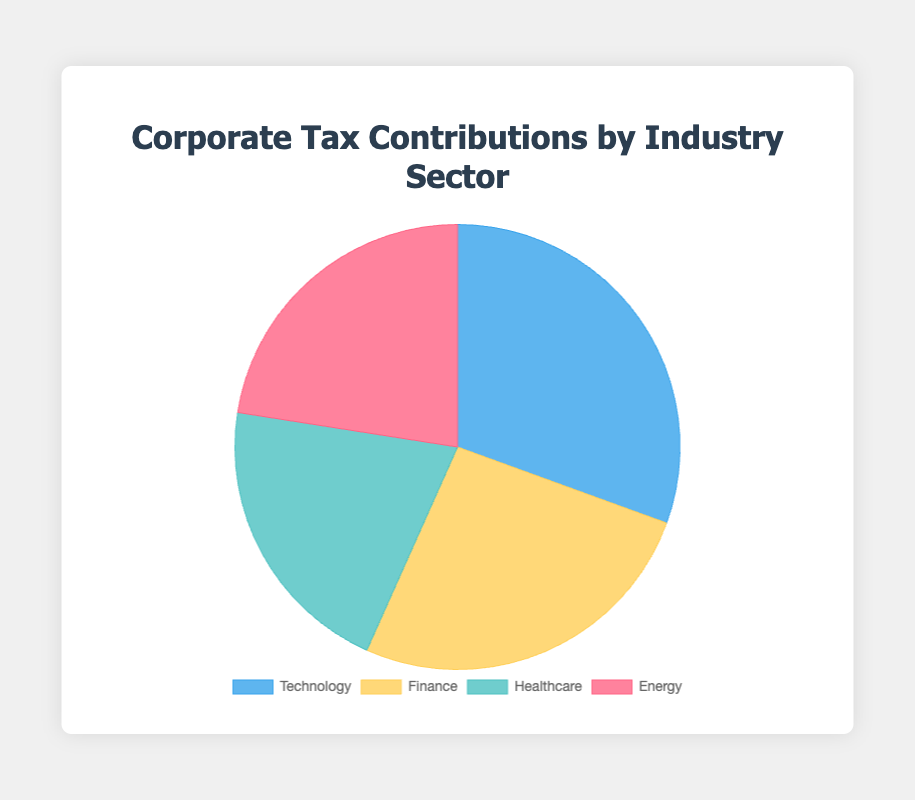Which industry sector has the highest corporate tax contributions? The pie chart shows four industry sectors with their respective tax contributions. By visually inspecting the chart, "Technology" has the largest segment.
Answer: Technology Which industry sector has the smallest corporate tax contributions? The chart segment with the smallest area represents the industry with the smallest tax contributions. This is "Healthcare".
Answer: Healthcare What is the combined tax contribution of the Finance and Energy sectors? By adding the tax contributions of Finance ($7,450) and Energy ($6,420), we get $7,450 + $6,420 = $13,870.
Answer: $13,870 How much more does Technology contribute in taxes compared to Healthcare? Subtract the tax contributions of Healthcare ($5,930) from Technology ($8,710). The difference is $8,710 - $5,930 = $2,780.
Answer: $2,780 What percentage of the total tax contributions is made by the Energy sector? First, find the total tax contributions: $8,710 (Technology) + $7,450 (Finance) + $5,930 (Healthcare) + $6,420 (Energy) = $28,510. Then, calculate the percentage for Energy: ($6,420 / $28,510) * 100 ≈ 22.52%.
Answer: 22.52% Between Finance and Technology, which sector contributes less in taxes and by how much? Finance has tax contributions of $7,450, and Technology has $8,710. The difference is $8,710 - $7,450 = $1,260. Finance contributes less by $1,260.
Answer: Finance, $1,260 What is the average corporate tax contribution across all sectors? First, find the total tax contributions: $8,710 (Technology) + $7,450 (Finance) + $5,930 (Healthcare) + $6,420 (Energy) = $28,510. Then divide by the number of sectors (4): $28,510 / 4 = $7,127.50.
Answer: $7,127.50 Which sector's tax contributions are closest to the average contribution? The average contribution is $7,127.50. Comparing all sectors: Technology ($8,710), Finance ($7,450), Healthcare ($5,930), and Energy ($6,420), the closest is Finance with $7,450 ($7,450 - $7,127.50 = $322.50).
Answer: Finance If Healthcare and Energy sectors combined their tax contributions, what fraction of the total tax contributions would their combined contribution represent? First, find their combined tax contributions: $5,930 (Healthcare) + $6,420 (Energy) = $12,350. The total tax contributions are $28,510. Therefore, the fraction is $12,350 / $28,510 ≈ 0.433 or 43.3%.
Answer: 43.3% 